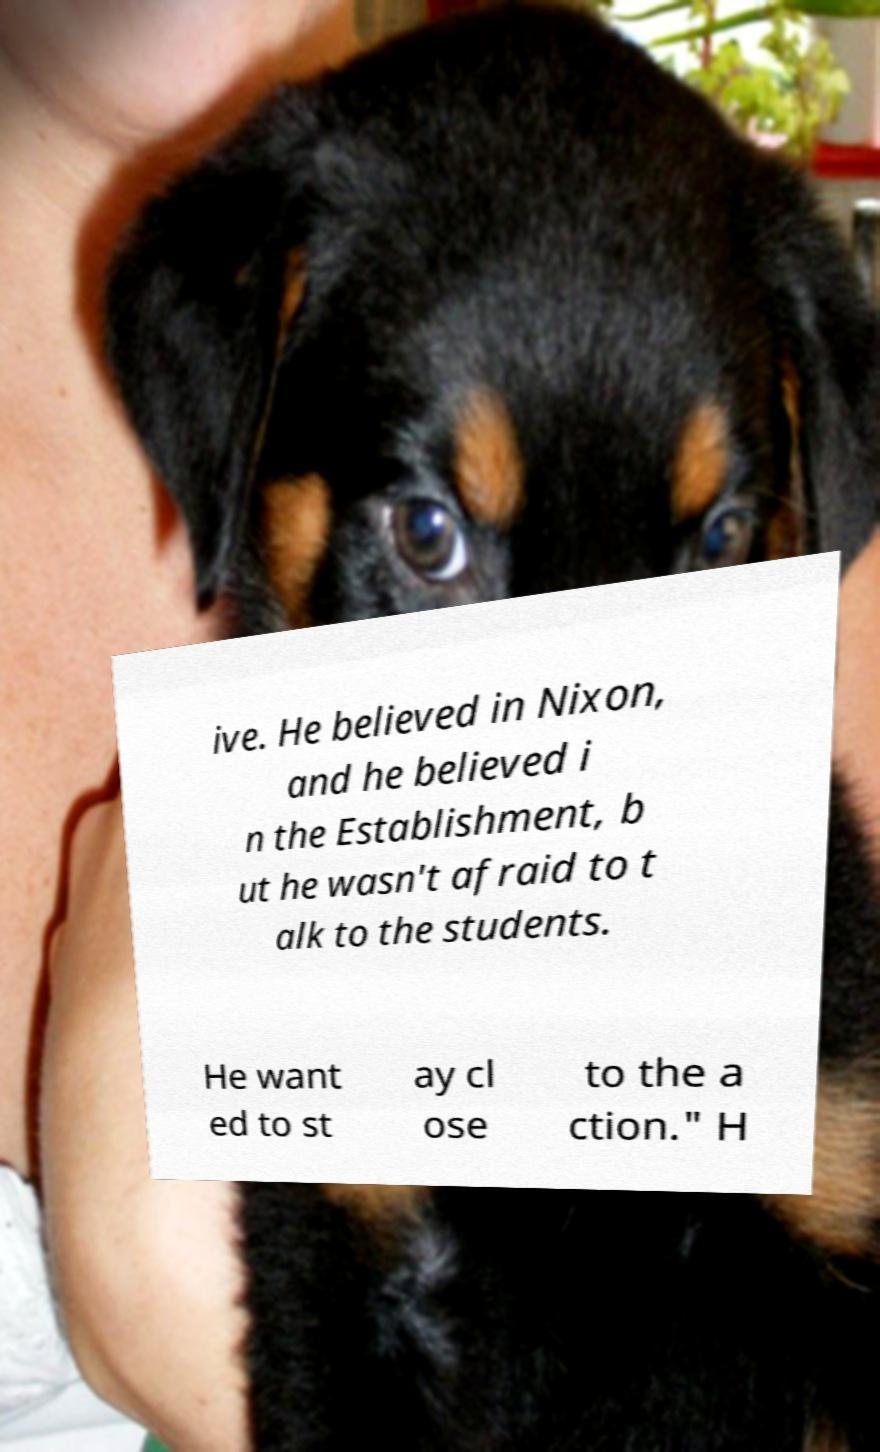Please read and relay the text visible in this image. What does it say? ive. He believed in Nixon, and he believed i n the Establishment, b ut he wasn't afraid to t alk to the students. He want ed to st ay cl ose to the a ction." H 